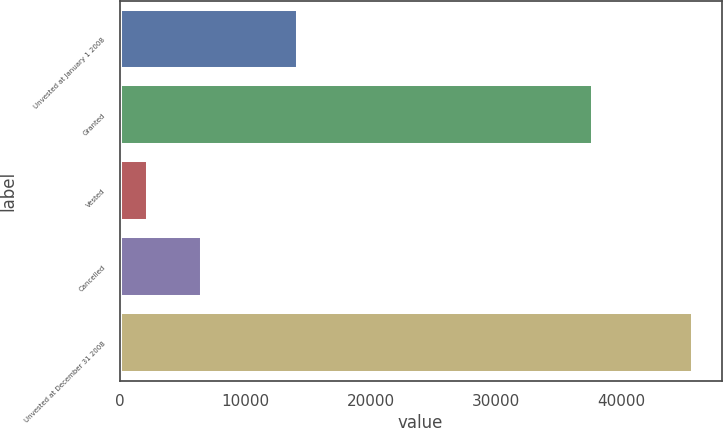<chart> <loc_0><loc_0><loc_500><loc_500><bar_chart><fcel>Unvested at January 1 2008<fcel>Granted<fcel>Vested<fcel>Cancelled<fcel>Unvested at December 31 2008<nl><fcel>14232<fcel>37747<fcel>2246<fcel>6591.8<fcel>45704<nl></chart> 